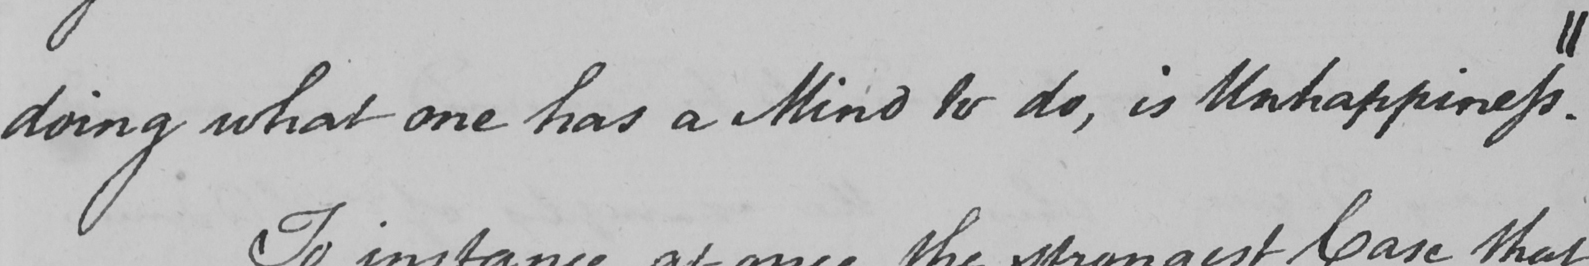What text is written in this handwritten line? doing what one has a Mind to do , is Unhappiness . || 